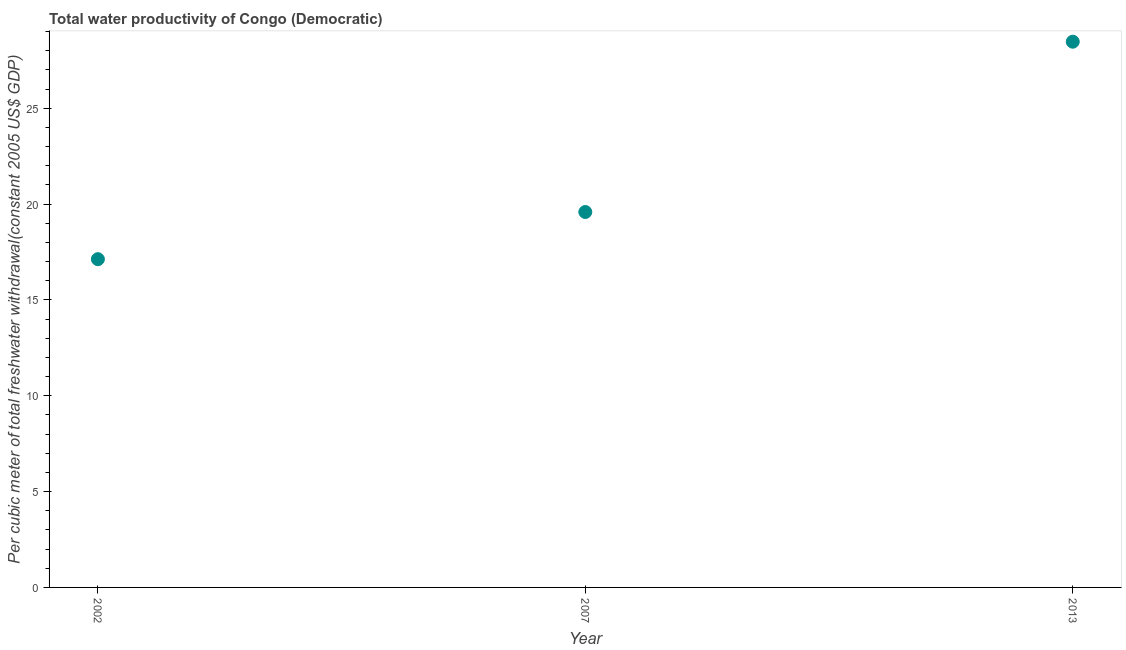What is the total water productivity in 2013?
Offer a terse response. 28.47. Across all years, what is the maximum total water productivity?
Your response must be concise. 28.47. Across all years, what is the minimum total water productivity?
Give a very brief answer. 17.13. In which year was the total water productivity maximum?
Your answer should be compact. 2013. What is the sum of the total water productivity?
Offer a very short reply. 65.19. What is the difference between the total water productivity in 2002 and 2013?
Offer a terse response. -11.35. What is the average total water productivity per year?
Your answer should be compact. 21.73. What is the median total water productivity?
Your response must be concise. 19.59. In how many years, is the total water productivity greater than 11 US$?
Your answer should be very brief. 3. What is the ratio of the total water productivity in 2002 to that in 2007?
Offer a terse response. 0.87. Is the difference between the total water productivity in 2007 and 2013 greater than the difference between any two years?
Keep it short and to the point. No. What is the difference between the highest and the second highest total water productivity?
Provide a succinct answer. 8.89. What is the difference between the highest and the lowest total water productivity?
Provide a succinct answer. 11.35. In how many years, is the total water productivity greater than the average total water productivity taken over all years?
Ensure brevity in your answer.  1. Does the total water productivity monotonically increase over the years?
Your answer should be very brief. Yes. How many years are there in the graph?
Offer a terse response. 3. What is the difference between two consecutive major ticks on the Y-axis?
Your answer should be compact. 5. Does the graph contain any zero values?
Your response must be concise. No. Does the graph contain grids?
Ensure brevity in your answer.  No. What is the title of the graph?
Make the answer very short. Total water productivity of Congo (Democratic). What is the label or title of the X-axis?
Keep it short and to the point. Year. What is the label or title of the Y-axis?
Your answer should be compact. Per cubic meter of total freshwater withdrawal(constant 2005 US$ GDP). What is the Per cubic meter of total freshwater withdrawal(constant 2005 US$ GDP) in 2002?
Provide a short and direct response. 17.13. What is the Per cubic meter of total freshwater withdrawal(constant 2005 US$ GDP) in 2007?
Provide a succinct answer. 19.59. What is the Per cubic meter of total freshwater withdrawal(constant 2005 US$ GDP) in 2013?
Offer a very short reply. 28.47. What is the difference between the Per cubic meter of total freshwater withdrawal(constant 2005 US$ GDP) in 2002 and 2007?
Keep it short and to the point. -2.46. What is the difference between the Per cubic meter of total freshwater withdrawal(constant 2005 US$ GDP) in 2002 and 2013?
Ensure brevity in your answer.  -11.35. What is the difference between the Per cubic meter of total freshwater withdrawal(constant 2005 US$ GDP) in 2007 and 2013?
Your response must be concise. -8.89. What is the ratio of the Per cubic meter of total freshwater withdrawal(constant 2005 US$ GDP) in 2002 to that in 2007?
Make the answer very short. 0.87. What is the ratio of the Per cubic meter of total freshwater withdrawal(constant 2005 US$ GDP) in 2002 to that in 2013?
Keep it short and to the point. 0.6. What is the ratio of the Per cubic meter of total freshwater withdrawal(constant 2005 US$ GDP) in 2007 to that in 2013?
Ensure brevity in your answer.  0.69. 